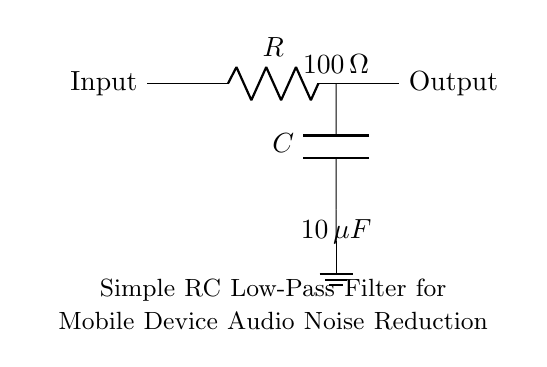What are the components in the circuit? The circuit contains a resistor and a capacitor, which are essential components of an RC low-pass filter.
Answer: resistor and capacitor What is the resistance value in this circuit? The value of the resistor in the circuit is indicated as one hundred ohms, which is a significant factor for determining the filter's cutoff frequency.
Answer: 100 ohm What is the capacitance value in this circuit? The capacitor is labeled with a capacitance of ten microfarads, which plays a crucial role in defining the filter's response to different frequencies.
Answer: 10 microfarads What is the purpose of this RC low-pass filter? The primary purpose of this low-pass filter is to reduce noise in audio signals, ensuring clearer sound output by allowing lower frequencies to pass while attenuating higher frequencies.
Answer: noise reduction How does the connection between the components affect noise reduction? The configuration, where the resistor is in series with the capacitor, enables the filter to react to high-frequency noise by shunting it to ground through the capacitor, thereby preventing it from passing to the output.
Answer: shunting to ground What type of filter does this circuit represent? This circuit represents a simple RC low-pass filter, which is commonly used in audio applications to improve sound quality by filtering out unwanted frequencies.
Answer: low-pass filter 